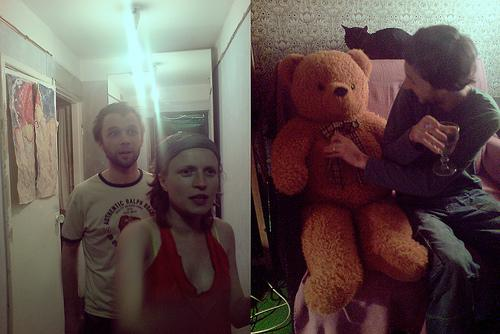Write a sentence describing the scene in the image, focusing on the interactions between the subjects. A man and woman stand next to a large teddy bear on a couch, with the man holding a glass and the black cat sitting behind them. Write a short description of the image from the perspective of the teddy bear. I am a large brown teddy bear with a plaid bow tie, and I am sitting on a couch surrounded by a man, a woman, and a black cat. Describe the scene in the image as if you were a reporter writing about a quirky art exhibit. In this peculiar exhibit, we observe a large brown teddy bear adorned with a plaid bowtie, sharing center stage with a man, a woman, and a secure black feline perched atop a couch back. Mention the main elements in the image with their colors and positions. A large brown teddy bear with a plaid bowtie, a man in a white shirt with black trim, a black cat on a couch back, and a woman in a red shirt and blue-gray bandana are the main elements. Form a haiku poem around the main elements in the image. Black cat watches all. Write a brief summary of the image from the viewpoint of an interior decorator. The room displays an eclectic mix of elements, including a cozy couch hosting a large teddy bear, a quaint painted picture on the wall, and a bright light in the background complementing the scene. Using casual language, briefly describe the outfits of the man and woman in the image. The dude's got a white shirt with some black trim and the gal's rockin' a red shirt along with a nice blue-gray bandana. What is the man doing with his right hand in the image? The man is holding a clear glass with his right hand. Using a casual tone, describe the main subjects and their interactions in the image. So there's this massive teddy bear on a couch, right? And a guy's next to it with a glass in his hand, while a lady in a red shirt just watches along, and this black cat's chilling on the back of the furniture. 